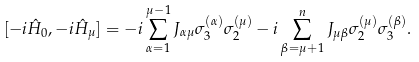Convert formula to latex. <formula><loc_0><loc_0><loc_500><loc_500>[ - i \hat { H } _ { 0 } , - i \hat { H } _ { \mu } ] = - i \sum _ { \alpha = 1 } ^ { \mu - 1 } J _ { \alpha \mu } \sigma ^ { ( \alpha ) } _ { 3 } \sigma ^ { ( \mu ) } _ { 2 } - i \sum _ { \beta = \mu + 1 } ^ { n } J _ { \mu \beta } \sigma ^ { ( \mu ) } _ { 2 } \sigma ^ { ( \beta ) } _ { 3 } .</formula> 